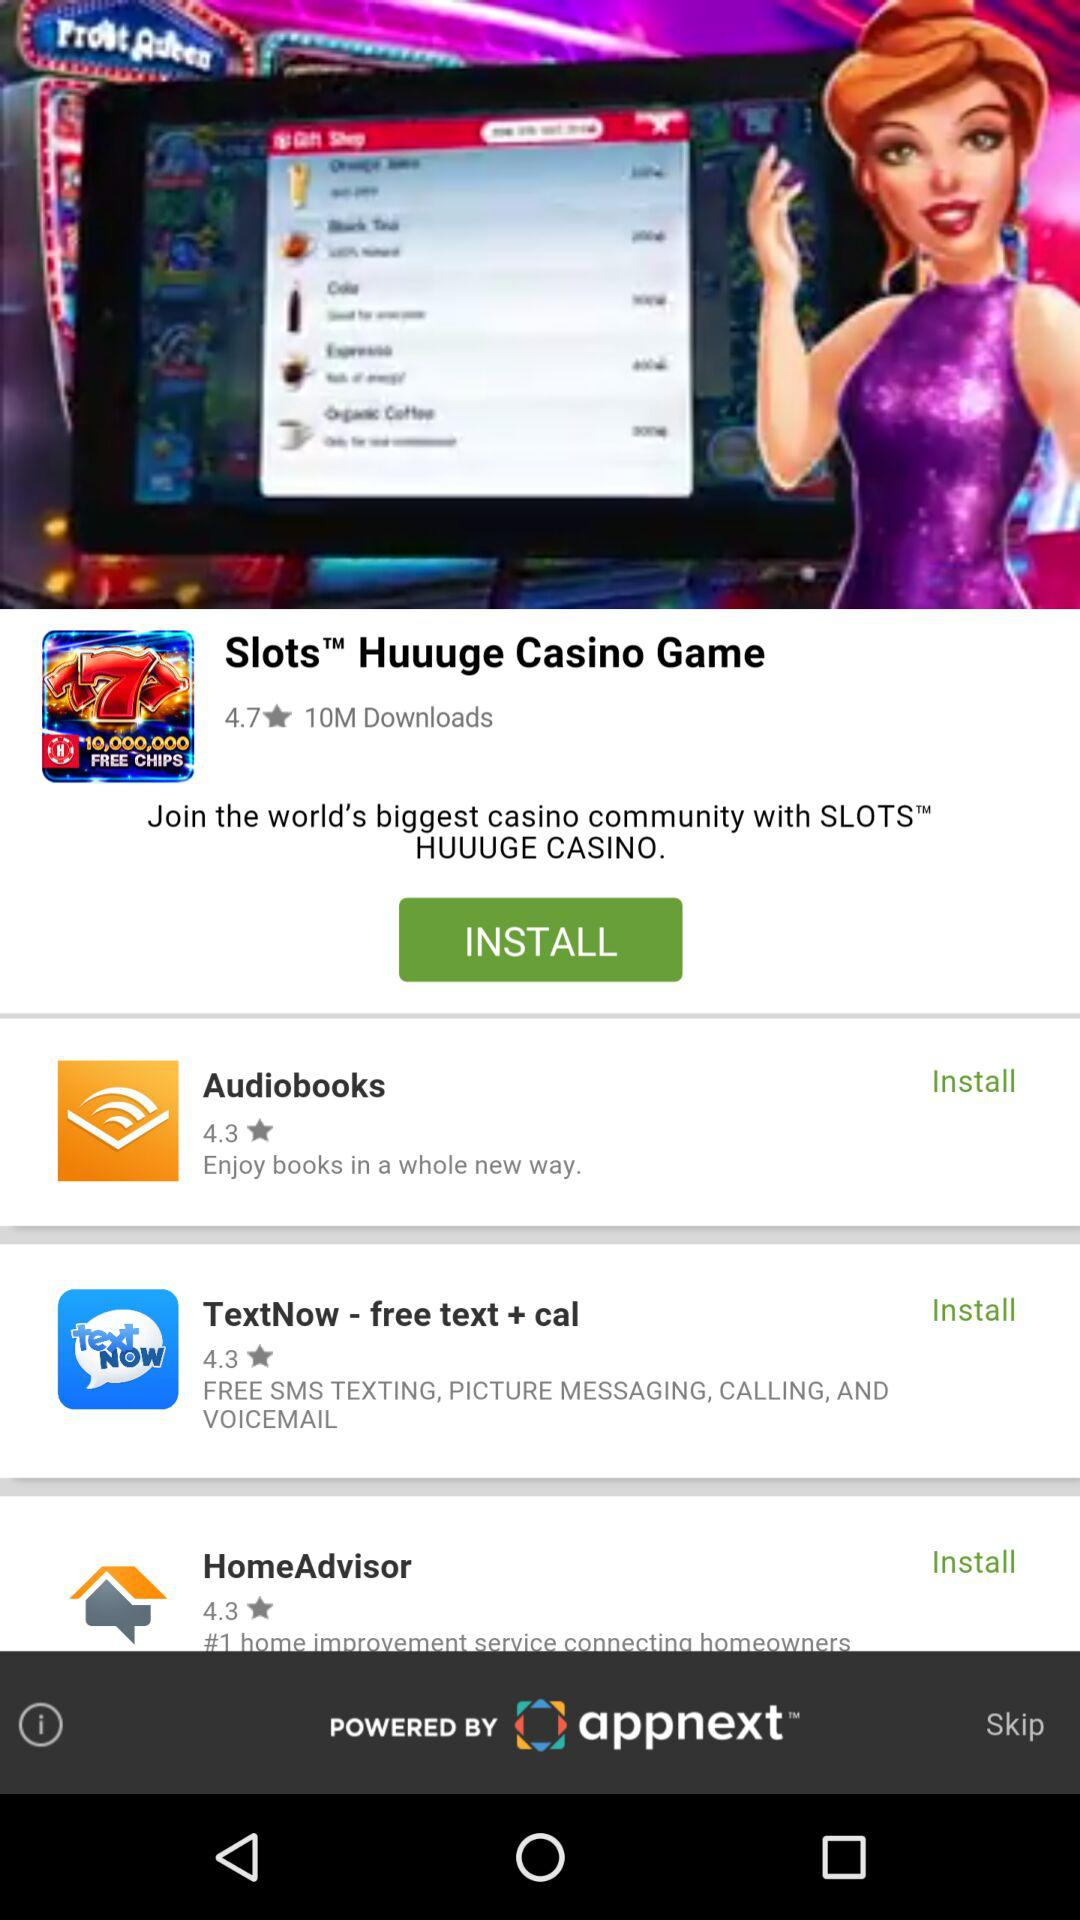What is the number of downloads? The number of downloads is 10 million. 